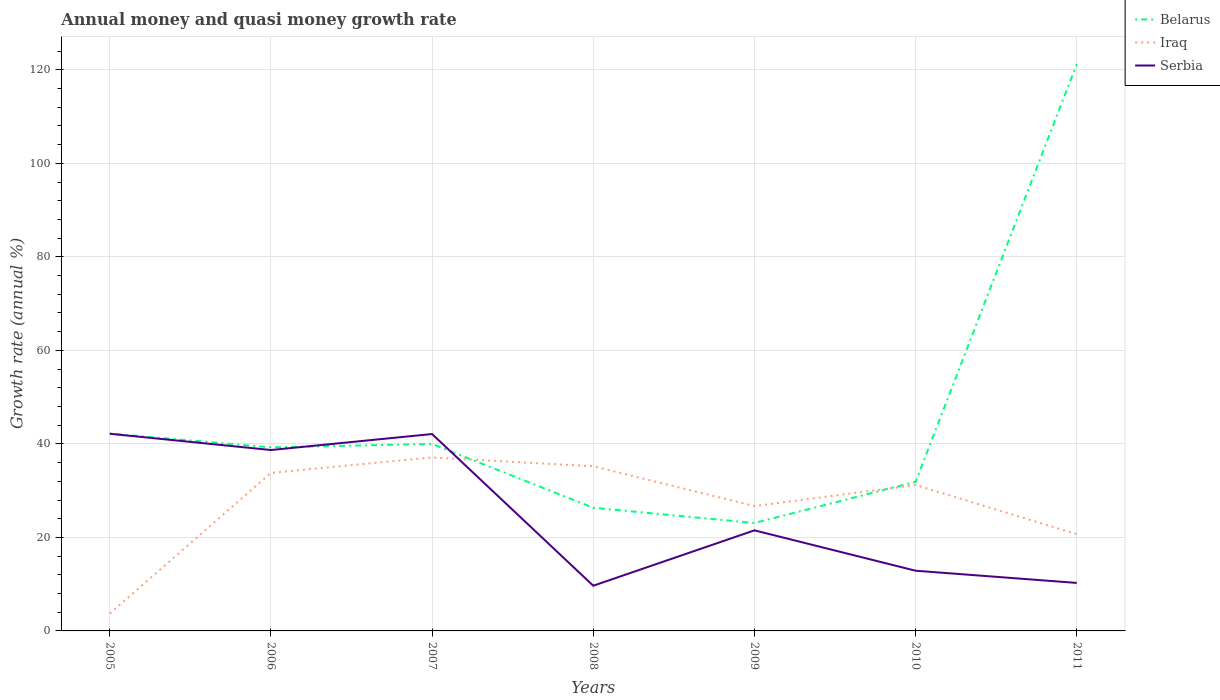Does the line corresponding to Belarus intersect with the line corresponding to Serbia?
Your answer should be compact. Yes. Is the number of lines equal to the number of legend labels?
Offer a terse response. Yes. Across all years, what is the maximum growth rate in Serbia?
Your answer should be compact. 9.67. In which year was the growth rate in Belarus maximum?
Make the answer very short. 2009. What is the total growth rate in Serbia in the graph?
Keep it short and to the point. 32.5. What is the difference between the highest and the second highest growth rate in Belarus?
Give a very brief answer. 98.16. What is the difference between the highest and the lowest growth rate in Belarus?
Your response must be concise. 1. Is the growth rate in Iraq strictly greater than the growth rate in Serbia over the years?
Make the answer very short. No. How many lines are there?
Provide a succinct answer. 3. Does the graph contain any zero values?
Provide a succinct answer. No. Where does the legend appear in the graph?
Keep it short and to the point. Top right. How many legend labels are there?
Keep it short and to the point. 3. What is the title of the graph?
Provide a succinct answer. Annual money and quasi money growth rate. Does "Panama" appear as one of the legend labels in the graph?
Offer a terse response. No. What is the label or title of the Y-axis?
Provide a succinct answer. Growth rate (annual %). What is the Growth rate (annual %) of Belarus in 2005?
Provide a short and direct response. 42.22. What is the Growth rate (annual %) of Iraq in 2005?
Ensure brevity in your answer.  3.71. What is the Growth rate (annual %) of Serbia in 2005?
Keep it short and to the point. 42.17. What is the Growth rate (annual %) of Belarus in 2006?
Provide a short and direct response. 39.26. What is the Growth rate (annual %) of Iraq in 2006?
Your response must be concise. 33.8. What is the Growth rate (annual %) in Serbia in 2006?
Keep it short and to the point. 38.69. What is the Growth rate (annual %) of Belarus in 2007?
Your answer should be compact. 39.99. What is the Growth rate (annual %) in Iraq in 2007?
Ensure brevity in your answer.  37.11. What is the Growth rate (annual %) in Serbia in 2007?
Offer a terse response. 42.11. What is the Growth rate (annual %) in Belarus in 2008?
Keep it short and to the point. 26.34. What is the Growth rate (annual %) of Iraq in 2008?
Make the answer very short. 35.22. What is the Growth rate (annual %) of Serbia in 2008?
Your response must be concise. 9.67. What is the Growth rate (annual %) in Belarus in 2009?
Offer a terse response. 23.08. What is the Growth rate (annual %) in Iraq in 2009?
Offer a terse response. 26.7. What is the Growth rate (annual %) of Serbia in 2009?
Your response must be concise. 21.51. What is the Growth rate (annual %) of Belarus in 2010?
Make the answer very short. 31.89. What is the Growth rate (annual %) in Iraq in 2010?
Give a very brief answer. 31.21. What is the Growth rate (annual %) of Serbia in 2010?
Keep it short and to the point. 12.87. What is the Growth rate (annual %) in Belarus in 2011?
Offer a very short reply. 121.24. What is the Growth rate (annual %) of Iraq in 2011?
Your answer should be very brief. 20.69. What is the Growth rate (annual %) of Serbia in 2011?
Ensure brevity in your answer.  10.26. Across all years, what is the maximum Growth rate (annual %) of Belarus?
Your answer should be compact. 121.24. Across all years, what is the maximum Growth rate (annual %) of Iraq?
Give a very brief answer. 37.11. Across all years, what is the maximum Growth rate (annual %) in Serbia?
Keep it short and to the point. 42.17. Across all years, what is the minimum Growth rate (annual %) in Belarus?
Your answer should be compact. 23.08. Across all years, what is the minimum Growth rate (annual %) of Iraq?
Provide a short and direct response. 3.71. Across all years, what is the minimum Growth rate (annual %) in Serbia?
Provide a short and direct response. 9.67. What is the total Growth rate (annual %) of Belarus in the graph?
Provide a short and direct response. 324.02. What is the total Growth rate (annual %) of Iraq in the graph?
Offer a very short reply. 188.43. What is the total Growth rate (annual %) in Serbia in the graph?
Give a very brief answer. 177.28. What is the difference between the Growth rate (annual %) in Belarus in 2005 and that in 2006?
Make the answer very short. 2.96. What is the difference between the Growth rate (annual %) in Iraq in 2005 and that in 2006?
Your answer should be very brief. -30.09. What is the difference between the Growth rate (annual %) of Serbia in 2005 and that in 2006?
Give a very brief answer. 3.48. What is the difference between the Growth rate (annual %) in Belarus in 2005 and that in 2007?
Keep it short and to the point. 2.23. What is the difference between the Growth rate (annual %) of Iraq in 2005 and that in 2007?
Your answer should be very brief. -33.4. What is the difference between the Growth rate (annual %) of Serbia in 2005 and that in 2007?
Offer a very short reply. 0.06. What is the difference between the Growth rate (annual %) in Belarus in 2005 and that in 2008?
Provide a succinct answer. 15.88. What is the difference between the Growth rate (annual %) in Iraq in 2005 and that in 2008?
Make the answer very short. -31.51. What is the difference between the Growth rate (annual %) of Serbia in 2005 and that in 2008?
Offer a terse response. 32.5. What is the difference between the Growth rate (annual %) of Belarus in 2005 and that in 2009?
Your response must be concise. 19.14. What is the difference between the Growth rate (annual %) in Iraq in 2005 and that in 2009?
Keep it short and to the point. -23. What is the difference between the Growth rate (annual %) of Serbia in 2005 and that in 2009?
Give a very brief answer. 20.66. What is the difference between the Growth rate (annual %) of Belarus in 2005 and that in 2010?
Your response must be concise. 10.32. What is the difference between the Growth rate (annual %) of Iraq in 2005 and that in 2010?
Provide a succinct answer. -27.5. What is the difference between the Growth rate (annual %) of Serbia in 2005 and that in 2010?
Provide a succinct answer. 29.29. What is the difference between the Growth rate (annual %) in Belarus in 2005 and that in 2011?
Make the answer very short. -79.02. What is the difference between the Growth rate (annual %) in Iraq in 2005 and that in 2011?
Offer a terse response. -16.99. What is the difference between the Growth rate (annual %) in Serbia in 2005 and that in 2011?
Provide a short and direct response. 31.9. What is the difference between the Growth rate (annual %) in Belarus in 2006 and that in 2007?
Provide a short and direct response. -0.73. What is the difference between the Growth rate (annual %) in Iraq in 2006 and that in 2007?
Ensure brevity in your answer.  -3.3. What is the difference between the Growth rate (annual %) in Serbia in 2006 and that in 2007?
Make the answer very short. -3.42. What is the difference between the Growth rate (annual %) in Belarus in 2006 and that in 2008?
Your response must be concise. 12.92. What is the difference between the Growth rate (annual %) in Iraq in 2006 and that in 2008?
Provide a short and direct response. -1.41. What is the difference between the Growth rate (annual %) of Serbia in 2006 and that in 2008?
Ensure brevity in your answer.  29.02. What is the difference between the Growth rate (annual %) of Belarus in 2006 and that in 2009?
Provide a succinct answer. 16.18. What is the difference between the Growth rate (annual %) of Iraq in 2006 and that in 2009?
Offer a terse response. 7.1. What is the difference between the Growth rate (annual %) of Serbia in 2006 and that in 2009?
Provide a short and direct response. 17.18. What is the difference between the Growth rate (annual %) in Belarus in 2006 and that in 2010?
Your answer should be very brief. 7.37. What is the difference between the Growth rate (annual %) in Iraq in 2006 and that in 2010?
Give a very brief answer. 2.59. What is the difference between the Growth rate (annual %) in Serbia in 2006 and that in 2010?
Offer a terse response. 25.81. What is the difference between the Growth rate (annual %) of Belarus in 2006 and that in 2011?
Offer a terse response. -81.98. What is the difference between the Growth rate (annual %) in Iraq in 2006 and that in 2011?
Ensure brevity in your answer.  13.11. What is the difference between the Growth rate (annual %) in Serbia in 2006 and that in 2011?
Your answer should be compact. 28.42. What is the difference between the Growth rate (annual %) in Belarus in 2007 and that in 2008?
Your answer should be very brief. 13.65. What is the difference between the Growth rate (annual %) in Iraq in 2007 and that in 2008?
Provide a short and direct response. 1.89. What is the difference between the Growth rate (annual %) of Serbia in 2007 and that in 2008?
Offer a terse response. 32.44. What is the difference between the Growth rate (annual %) in Belarus in 2007 and that in 2009?
Your answer should be compact. 16.91. What is the difference between the Growth rate (annual %) of Iraq in 2007 and that in 2009?
Your response must be concise. 10.4. What is the difference between the Growth rate (annual %) in Serbia in 2007 and that in 2009?
Ensure brevity in your answer.  20.6. What is the difference between the Growth rate (annual %) of Belarus in 2007 and that in 2010?
Make the answer very short. 8.1. What is the difference between the Growth rate (annual %) of Iraq in 2007 and that in 2010?
Provide a succinct answer. 5.9. What is the difference between the Growth rate (annual %) in Serbia in 2007 and that in 2010?
Ensure brevity in your answer.  29.24. What is the difference between the Growth rate (annual %) in Belarus in 2007 and that in 2011?
Offer a terse response. -81.25. What is the difference between the Growth rate (annual %) in Iraq in 2007 and that in 2011?
Provide a short and direct response. 16.41. What is the difference between the Growth rate (annual %) in Serbia in 2007 and that in 2011?
Provide a succinct answer. 31.85. What is the difference between the Growth rate (annual %) in Belarus in 2008 and that in 2009?
Ensure brevity in your answer.  3.26. What is the difference between the Growth rate (annual %) of Iraq in 2008 and that in 2009?
Provide a succinct answer. 8.51. What is the difference between the Growth rate (annual %) of Serbia in 2008 and that in 2009?
Ensure brevity in your answer.  -11.84. What is the difference between the Growth rate (annual %) of Belarus in 2008 and that in 2010?
Your answer should be compact. -5.55. What is the difference between the Growth rate (annual %) of Iraq in 2008 and that in 2010?
Your response must be concise. 4.01. What is the difference between the Growth rate (annual %) of Serbia in 2008 and that in 2010?
Provide a succinct answer. -3.21. What is the difference between the Growth rate (annual %) of Belarus in 2008 and that in 2011?
Offer a terse response. -94.9. What is the difference between the Growth rate (annual %) in Iraq in 2008 and that in 2011?
Give a very brief answer. 14.52. What is the difference between the Growth rate (annual %) in Serbia in 2008 and that in 2011?
Provide a short and direct response. -0.6. What is the difference between the Growth rate (annual %) of Belarus in 2009 and that in 2010?
Your answer should be compact. -8.81. What is the difference between the Growth rate (annual %) of Iraq in 2009 and that in 2010?
Keep it short and to the point. -4.5. What is the difference between the Growth rate (annual %) in Serbia in 2009 and that in 2010?
Offer a very short reply. 8.64. What is the difference between the Growth rate (annual %) in Belarus in 2009 and that in 2011?
Your answer should be compact. -98.16. What is the difference between the Growth rate (annual %) of Iraq in 2009 and that in 2011?
Give a very brief answer. 6.01. What is the difference between the Growth rate (annual %) in Serbia in 2009 and that in 2011?
Offer a very short reply. 11.25. What is the difference between the Growth rate (annual %) of Belarus in 2010 and that in 2011?
Provide a short and direct response. -89.35. What is the difference between the Growth rate (annual %) of Iraq in 2010 and that in 2011?
Ensure brevity in your answer.  10.51. What is the difference between the Growth rate (annual %) of Serbia in 2010 and that in 2011?
Give a very brief answer. 2.61. What is the difference between the Growth rate (annual %) of Belarus in 2005 and the Growth rate (annual %) of Iraq in 2006?
Your response must be concise. 8.42. What is the difference between the Growth rate (annual %) in Belarus in 2005 and the Growth rate (annual %) in Serbia in 2006?
Provide a short and direct response. 3.53. What is the difference between the Growth rate (annual %) in Iraq in 2005 and the Growth rate (annual %) in Serbia in 2006?
Keep it short and to the point. -34.98. What is the difference between the Growth rate (annual %) in Belarus in 2005 and the Growth rate (annual %) in Iraq in 2007?
Provide a succinct answer. 5.11. What is the difference between the Growth rate (annual %) of Belarus in 2005 and the Growth rate (annual %) of Serbia in 2007?
Provide a succinct answer. 0.11. What is the difference between the Growth rate (annual %) in Iraq in 2005 and the Growth rate (annual %) in Serbia in 2007?
Give a very brief answer. -38.4. What is the difference between the Growth rate (annual %) of Belarus in 2005 and the Growth rate (annual %) of Iraq in 2008?
Offer a very short reply. 7. What is the difference between the Growth rate (annual %) in Belarus in 2005 and the Growth rate (annual %) in Serbia in 2008?
Your answer should be very brief. 32.55. What is the difference between the Growth rate (annual %) in Iraq in 2005 and the Growth rate (annual %) in Serbia in 2008?
Offer a very short reply. -5.96. What is the difference between the Growth rate (annual %) in Belarus in 2005 and the Growth rate (annual %) in Iraq in 2009?
Your answer should be very brief. 15.51. What is the difference between the Growth rate (annual %) of Belarus in 2005 and the Growth rate (annual %) of Serbia in 2009?
Keep it short and to the point. 20.71. What is the difference between the Growth rate (annual %) in Iraq in 2005 and the Growth rate (annual %) in Serbia in 2009?
Provide a short and direct response. -17.8. What is the difference between the Growth rate (annual %) of Belarus in 2005 and the Growth rate (annual %) of Iraq in 2010?
Make the answer very short. 11.01. What is the difference between the Growth rate (annual %) of Belarus in 2005 and the Growth rate (annual %) of Serbia in 2010?
Ensure brevity in your answer.  29.34. What is the difference between the Growth rate (annual %) of Iraq in 2005 and the Growth rate (annual %) of Serbia in 2010?
Your response must be concise. -9.17. What is the difference between the Growth rate (annual %) in Belarus in 2005 and the Growth rate (annual %) in Iraq in 2011?
Provide a succinct answer. 21.52. What is the difference between the Growth rate (annual %) of Belarus in 2005 and the Growth rate (annual %) of Serbia in 2011?
Keep it short and to the point. 31.95. What is the difference between the Growth rate (annual %) in Iraq in 2005 and the Growth rate (annual %) in Serbia in 2011?
Your answer should be very brief. -6.56. What is the difference between the Growth rate (annual %) of Belarus in 2006 and the Growth rate (annual %) of Iraq in 2007?
Your response must be concise. 2.16. What is the difference between the Growth rate (annual %) of Belarus in 2006 and the Growth rate (annual %) of Serbia in 2007?
Provide a short and direct response. -2.85. What is the difference between the Growth rate (annual %) in Iraq in 2006 and the Growth rate (annual %) in Serbia in 2007?
Your answer should be compact. -8.31. What is the difference between the Growth rate (annual %) in Belarus in 2006 and the Growth rate (annual %) in Iraq in 2008?
Provide a short and direct response. 4.05. What is the difference between the Growth rate (annual %) in Belarus in 2006 and the Growth rate (annual %) in Serbia in 2008?
Offer a terse response. 29.59. What is the difference between the Growth rate (annual %) in Iraq in 2006 and the Growth rate (annual %) in Serbia in 2008?
Offer a very short reply. 24.13. What is the difference between the Growth rate (annual %) in Belarus in 2006 and the Growth rate (annual %) in Iraq in 2009?
Provide a succinct answer. 12.56. What is the difference between the Growth rate (annual %) of Belarus in 2006 and the Growth rate (annual %) of Serbia in 2009?
Provide a short and direct response. 17.75. What is the difference between the Growth rate (annual %) in Iraq in 2006 and the Growth rate (annual %) in Serbia in 2009?
Provide a short and direct response. 12.29. What is the difference between the Growth rate (annual %) of Belarus in 2006 and the Growth rate (annual %) of Iraq in 2010?
Offer a very short reply. 8.05. What is the difference between the Growth rate (annual %) of Belarus in 2006 and the Growth rate (annual %) of Serbia in 2010?
Make the answer very short. 26.39. What is the difference between the Growth rate (annual %) of Iraq in 2006 and the Growth rate (annual %) of Serbia in 2010?
Your answer should be very brief. 20.93. What is the difference between the Growth rate (annual %) of Belarus in 2006 and the Growth rate (annual %) of Iraq in 2011?
Keep it short and to the point. 18.57. What is the difference between the Growth rate (annual %) in Belarus in 2006 and the Growth rate (annual %) in Serbia in 2011?
Your answer should be very brief. 29. What is the difference between the Growth rate (annual %) of Iraq in 2006 and the Growth rate (annual %) of Serbia in 2011?
Ensure brevity in your answer.  23.54. What is the difference between the Growth rate (annual %) in Belarus in 2007 and the Growth rate (annual %) in Iraq in 2008?
Ensure brevity in your answer.  4.77. What is the difference between the Growth rate (annual %) of Belarus in 2007 and the Growth rate (annual %) of Serbia in 2008?
Offer a terse response. 30.32. What is the difference between the Growth rate (annual %) in Iraq in 2007 and the Growth rate (annual %) in Serbia in 2008?
Provide a short and direct response. 27.44. What is the difference between the Growth rate (annual %) in Belarus in 2007 and the Growth rate (annual %) in Iraq in 2009?
Make the answer very short. 13.28. What is the difference between the Growth rate (annual %) in Belarus in 2007 and the Growth rate (annual %) in Serbia in 2009?
Your answer should be compact. 18.48. What is the difference between the Growth rate (annual %) in Iraq in 2007 and the Growth rate (annual %) in Serbia in 2009?
Provide a short and direct response. 15.59. What is the difference between the Growth rate (annual %) of Belarus in 2007 and the Growth rate (annual %) of Iraq in 2010?
Offer a terse response. 8.78. What is the difference between the Growth rate (annual %) in Belarus in 2007 and the Growth rate (annual %) in Serbia in 2010?
Your answer should be very brief. 27.11. What is the difference between the Growth rate (annual %) in Iraq in 2007 and the Growth rate (annual %) in Serbia in 2010?
Your answer should be compact. 24.23. What is the difference between the Growth rate (annual %) in Belarus in 2007 and the Growth rate (annual %) in Iraq in 2011?
Your answer should be compact. 19.29. What is the difference between the Growth rate (annual %) in Belarus in 2007 and the Growth rate (annual %) in Serbia in 2011?
Keep it short and to the point. 29.72. What is the difference between the Growth rate (annual %) of Iraq in 2007 and the Growth rate (annual %) of Serbia in 2011?
Offer a terse response. 26.84. What is the difference between the Growth rate (annual %) of Belarus in 2008 and the Growth rate (annual %) of Iraq in 2009?
Give a very brief answer. -0.36. What is the difference between the Growth rate (annual %) of Belarus in 2008 and the Growth rate (annual %) of Serbia in 2009?
Make the answer very short. 4.83. What is the difference between the Growth rate (annual %) in Iraq in 2008 and the Growth rate (annual %) in Serbia in 2009?
Provide a short and direct response. 13.7. What is the difference between the Growth rate (annual %) of Belarus in 2008 and the Growth rate (annual %) of Iraq in 2010?
Offer a very short reply. -4.87. What is the difference between the Growth rate (annual %) of Belarus in 2008 and the Growth rate (annual %) of Serbia in 2010?
Give a very brief answer. 13.47. What is the difference between the Growth rate (annual %) in Iraq in 2008 and the Growth rate (annual %) in Serbia in 2010?
Your response must be concise. 22.34. What is the difference between the Growth rate (annual %) in Belarus in 2008 and the Growth rate (annual %) in Iraq in 2011?
Provide a succinct answer. 5.65. What is the difference between the Growth rate (annual %) of Belarus in 2008 and the Growth rate (annual %) of Serbia in 2011?
Offer a terse response. 16.08. What is the difference between the Growth rate (annual %) in Iraq in 2008 and the Growth rate (annual %) in Serbia in 2011?
Your answer should be very brief. 24.95. What is the difference between the Growth rate (annual %) of Belarus in 2009 and the Growth rate (annual %) of Iraq in 2010?
Your response must be concise. -8.13. What is the difference between the Growth rate (annual %) in Belarus in 2009 and the Growth rate (annual %) in Serbia in 2010?
Your answer should be very brief. 10.21. What is the difference between the Growth rate (annual %) of Iraq in 2009 and the Growth rate (annual %) of Serbia in 2010?
Keep it short and to the point. 13.83. What is the difference between the Growth rate (annual %) of Belarus in 2009 and the Growth rate (annual %) of Iraq in 2011?
Your answer should be compact. 2.39. What is the difference between the Growth rate (annual %) in Belarus in 2009 and the Growth rate (annual %) in Serbia in 2011?
Keep it short and to the point. 12.82. What is the difference between the Growth rate (annual %) of Iraq in 2009 and the Growth rate (annual %) of Serbia in 2011?
Provide a short and direct response. 16.44. What is the difference between the Growth rate (annual %) in Belarus in 2010 and the Growth rate (annual %) in Iraq in 2011?
Keep it short and to the point. 11.2. What is the difference between the Growth rate (annual %) of Belarus in 2010 and the Growth rate (annual %) of Serbia in 2011?
Your answer should be very brief. 21.63. What is the difference between the Growth rate (annual %) in Iraq in 2010 and the Growth rate (annual %) in Serbia in 2011?
Your answer should be very brief. 20.94. What is the average Growth rate (annual %) in Belarus per year?
Offer a very short reply. 46.29. What is the average Growth rate (annual %) in Iraq per year?
Your response must be concise. 26.92. What is the average Growth rate (annual %) in Serbia per year?
Ensure brevity in your answer.  25.33. In the year 2005, what is the difference between the Growth rate (annual %) in Belarus and Growth rate (annual %) in Iraq?
Offer a terse response. 38.51. In the year 2005, what is the difference between the Growth rate (annual %) in Belarus and Growth rate (annual %) in Serbia?
Keep it short and to the point. 0.05. In the year 2005, what is the difference between the Growth rate (annual %) of Iraq and Growth rate (annual %) of Serbia?
Ensure brevity in your answer.  -38.46. In the year 2006, what is the difference between the Growth rate (annual %) in Belarus and Growth rate (annual %) in Iraq?
Your answer should be very brief. 5.46. In the year 2006, what is the difference between the Growth rate (annual %) in Belarus and Growth rate (annual %) in Serbia?
Give a very brief answer. 0.57. In the year 2006, what is the difference between the Growth rate (annual %) of Iraq and Growth rate (annual %) of Serbia?
Offer a very short reply. -4.89. In the year 2007, what is the difference between the Growth rate (annual %) of Belarus and Growth rate (annual %) of Iraq?
Offer a very short reply. 2.88. In the year 2007, what is the difference between the Growth rate (annual %) in Belarus and Growth rate (annual %) in Serbia?
Keep it short and to the point. -2.12. In the year 2007, what is the difference between the Growth rate (annual %) in Iraq and Growth rate (annual %) in Serbia?
Offer a very short reply. -5. In the year 2008, what is the difference between the Growth rate (annual %) of Belarus and Growth rate (annual %) of Iraq?
Your response must be concise. -8.87. In the year 2008, what is the difference between the Growth rate (annual %) in Belarus and Growth rate (annual %) in Serbia?
Provide a short and direct response. 16.67. In the year 2008, what is the difference between the Growth rate (annual %) in Iraq and Growth rate (annual %) in Serbia?
Ensure brevity in your answer.  25.55. In the year 2009, what is the difference between the Growth rate (annual %) of Belarus and Growth rate (annual %) of Iraq?
Offer a terse response. -3.62. In the year 2009, what is the difference between the Growth rate (annual %) in Belarus and Growth rate (annual %) in Serbia?
Provide a short and direct response. 1.57. In the year 2009, what is the difference between the Growth rate (annual %) of Iraq and Growth rate (annual %) of Serbia?
Ensure brevity in your answer.  5.19. In the year 2010, what is the difference between the Growth rate (annual %) in Belarus and Growth rate (annual %) in Iraq?
Offer a terse response. 0.69. In the year 2010, what is the difference between the Growth rate (annual %) of Belarus and Growth rate (annual %) of Serbia?
Offer a terse response. 19.02. In the year 2010, what is the difference between the Growth rate (annual %) of Iraq and Growth rate (annual %) of Serbia?
Your answer should be compact. 18.33. In the year 2011, what is the difference between the Growth rate (annual %) of Belarus and Growth rate (annual %) of Iraq?
Provide a succinct answer. 100.55. In the year 2011, what is the difference between the Growth rate (annual %) in Belarus and Growth rate (annual %) in Serbia?
Provide a short and direct response. 110.98. In the year 2011, what is the difference between the Growth rate (annual %) of Iraq and Growth rate (annual %) of Serbia?
Offer a terse response. 10.43. What is the ratio of the Growth rate (annual %) of Belarus in 2005 to that in 2006?
Your response must be concise. 1.08. What is the ratio of the Growth rate (annual %) of Iraq in 2005 to that in 2006?
Give a very brief answer. 0.11. What is the ratio of the Growth rate (annual %) in Serbia in 2005 to that in 2006?
Provide a succinct answer. 1.09. What is the ratio of the Growth rate (annual %) of Belarus in 2005 to that in 2007?
Your answer should be very brief. 1.06. What is the ratio of the Growth rate (annual %) of Iraq in 2005 to that in 2007?
Ensure brevity in your answer.  0.1. What is the ratio of the Growth rate (annual %) in Serbia in 2005 to that in 2007?
Offer a very short reply. 1. What is the ratio of the Growth rate (annual %) of Belarus in 2005 to that in 2008?
Your answer should be compact. 1.6. What is the ratio of the Growth rate (annual %) in Iraq in 2005 to that in 2008?
Give a very brief answer. 0.11. What is the ratio of the Growth rate (annual %) of Serbia in 2005 to that in 2008?
Your response must be concise. 4.36. What is the ratio of the Growth rate (annual %) in Belarus in 2005 to that in 2009?
Ensure brevity in your answer.  1.83. What is the ratio of the Growth rate (annual %) of Iraq in 2005 to that in 2009?
Offer a terse response. 0.14. What is the ratio of the Growth rate (annual %) of Serbia in 2005 to that in 2009?
Provide a succinct answer. 1.96. What is the ratio of the Growth rate (annual %) in Belarus in 2005 to that in 2010?
Keep it short and to the point. 1.32. What is the ratio of the Growth rate (annual %) in Iraq in 2005 to that in 2010?
Your answer should be compact. 0.12. What is the ratio of the Growth rate (annual %) of Serbia in 2005 to that in 2010?
Offer a very short reply. 3.28. What is the ratio of the Growth rate (annual %) of Belarus in 2005 to that in 2011?
Make the answer very short. 0.35. What is the ratio of the Growth rate (annual %) in Iraq in 2005 to that in 2011?
Keep it short and to the point. 0.18. What is the ratio of the Growth rate (annual %) in Serbia in 2005 to that in 2011?
Offer a very short reply. 4.11. What is the ratio of the Growth rate (annual %) in Belarus in 2006 to that in 2007?
Offer a terse response. 0.98. What is the ratio of the Growth rate (annual %) of Iraq in 2006 to that in 2007?
Ensure brevity in your answer.  0.91. What is the ratio of the Growth rate (annual %) of Serbia in 2006 to that in 2007?
Make the answer very short. 0.92. What is the ratio of the Growth rate (annual %) in Belarus in 2006 to that in 2008?
Give a very brief answer. 1.49. What is the ratio of the Growth rate (annual %) of Iraq in 2006 to that in 2008?
Provide a short and direct response. 0.96. What is the ratio of the Growth rate (annual %) of Serbia in 2006 to that in 2008?
Make the answer very short. 4. What is the ratio of the Growth rate (annual %) of Belarus in 2006 to that in 2009?
Offer a very short reply. 1.7. What is the ratio of the Growth rate (annual %) of Iraq in 2006 to that in 2009?
Keep it short and to the point. 1.27. What is the ratio of the Growth rate (annual %) of Serbia in 2006 to that in 2009?
Offer a terse response. 1.8. What is the ratio of the Growth rate (annual %) of Belarus in 2006 to that in 2010?
Provide a succinct answer. 1.23. What is the ratio of the Growth rate (annual %) of Iraq in 2006 to that in 2010?
Offer a very short reply. 1.08. What is the ratio of the Growth rate (annual %) in Serbia in 2006 to that in 2010?
Ensure brevity in your answer.  3.01. What is the ratio of the Growth rate (annual %) of Belarus in 2006 to that in 2011?
Your answer should be compact. 0.32. What is the ratio of the Growth rate (annual %) of Iraq in 2006 to that in 2011?
Offer a very short reply. 1.63. What is the ratio of the Growth rate (annual %) in Serbia in 2006 to that in 2011?
Your response must be concise. 3.77. What is the ratio of the Growth rate (annual %) in Belarus in 2007 to that in 2008?
Ensure brevity in your answer.  1.52. What is the ratio of the Growth rate (annual %) of Iraq in 2007 to that in 2008?
Give a very brief answer. 1.05. What is the ratio of the Growth rate (annual %) in Serbia in 2007 to that in 2008?
Keep it short and to the point. 4.36. What is the ratio of the Growth rate (annual %) of Belarus in 2007 to that in 2009?
Give a very brief answer. 1.73. What is the ratio of the Growth rate (annual %) of Iraq in 2007 to that in 2009?
Provide a succinct answer. 1.39. What is the ratio of the Growth rate (annual %) in Serbia in 2007 to that in 2009?
Provide a succinct answer. 1.96. What is the ratio of the Growth rate (annual %) in Belarus in 2007 to that in 2010?
Make the answer very short. 1.25. What is the ratio of the Growth rate (annual %) of Iraq in 2007 to that in 2010?
Offer a terse response. 1.19. What is the ratio of the Growth rate (annual %) in Serbia in 2007 to that in 2010?
Your response must be concise. 3.27. What is the ratio of the Growth rate (annual %) of Belarus in 2007 to that in 2011?
Offer a very short reply. 0.33. What is the ratio of the Growth rate (annual %) in Iraq in 2007 to that in 2011?
Make the answer very short. 1.79. What is the ratio of the Growth rate (annual %) in Serbia in 2007 to that in 2011?
Keep it short and to the point. 4.1. What is the ratio of the Growth rate (annual %) of Belarus in 2008 to that in 2009?
Provide a succinct answer. 1.14. What is the ratio of the Growth rate (annual %) in Iraq in 2008 to that in 2009?
Your answer should be compact. 1.32. What is the ratio of the Growth rate (annual %) in Serbia in 2008 to that in 2009?
Give a very brief answer. 0.45. What is the ratio of the Growth rate (annual %) of Belarus in 2008 to that in 2010?
Make the answer very short. 0.83. What is the ratio of the Growth rate (annual %) in Iraq in 2008 to that in 2010?
Your answer should be compact. 1.13. What is the ratio of the Growth rate (annual %) in Serbia in 2008 to that in 2010?
Provide a succinct answer. 0.75. What is the ratio of the Growth rate (annual %) in Belarus in 2008 to that in 2011?
Make the answer very short. 0.22. What is the ratio of the Growth rate (annual %) in Iraq in 2008 to that in 2011?
Provide a short and direct response. 1.7. What is the ratio of the Growth rate (annual %) of Serbia in 2008 to that in 2011?
Offer a terse response. 0.94. What is the ratio of the Growth rate (annual %) in Belarus in 2009 to that in 2010?
Ensure brevity in your answer.  0.72. What is the ratio of the Growth rate (annual %) in Iraq in 2009 to that in 2010?
Your answer should be very brief. 0.86. What is the ratio of the Growth rate (annual %) of Serbia in 2009 to that in 2010?
Your answer should be compact. 1.67. What is the ratio of the Growth rate (annual %) of Belarus in 2009 to that in 2011?
Offer a terse response. 0.19. What is the ratio of the Growth rate (annual %) in Iraq in 2009 to that in 2011?
Your response must be concise. 1.29. What is the ratio of the Growth rate (annual %) of Serbia in 2009 to that in 2011?
Provide a short and direct response. 2.1. What is the ratio of the Growth rate (annual %) in Belarus in 2010 to that in 2011?
Provide a short and direct response. 0.26. What is the ratio of the Growth rate (annual %) in Iraq in 2010 to that in 2011?
Provide a short and direct response. 1.51. What is the ratio of the Growth rate (annual %) of Serbia in 2010 to that in 2011?
Provide a short and direct response. 1.25. What is the difference between the highest and the second highest Growth rate (annual %) in Belarus?
Provide a short and direct response. 79.02. What is the difference between the highest and the second highest Growth rate (annual %) of Iraq?
Give a very brief answer. 1.89. What is the difference between the highest and the second highest Growth rate (annual %) of Serbia?
Your response must be concise. 0.06. What is the difference between the highest and the lowest Growth rate (annual %) in Belarus?
Keep it short and to the point. 98.16. What is the difference between the highest and the lowest Growth rate (annual %) in Iraq?
Give a very brief answer. 33.4. What is the difference between the highest and the lowest Growth rate (annual %) of Serbia?
Provide a succinct answer. 32.5. 